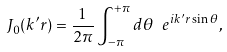<formula> <loc_0><loc_0><loc_500><loc_500>J _ { 0 } ( k ^ { \prime } r ) = \frac { 1 } { 2 \pi } \int _ { - \pi } ^ { + \pi } d \theta \ e ^ { i k ^ { \prime } r \sin \theta } ,</formula> 